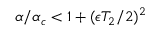<formula> <loc_0><loc_0><loc_500><loc_500>\alpha / \alpha _ { c } < 1 + ( \epsilon T _ { 2 } / 2 ) ^ { 2 }</formula> 